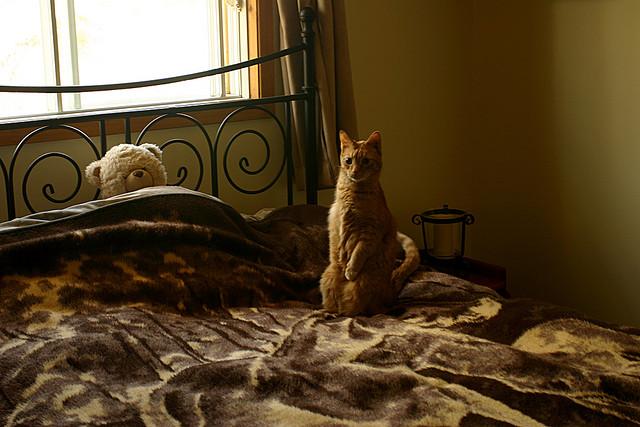Is the cat standing?
Be succinct. Yes. What is the candle sitting on?
Answer briefly. Table. Is the teddy bear ready for a nap?
Quick response, please. Yes. 